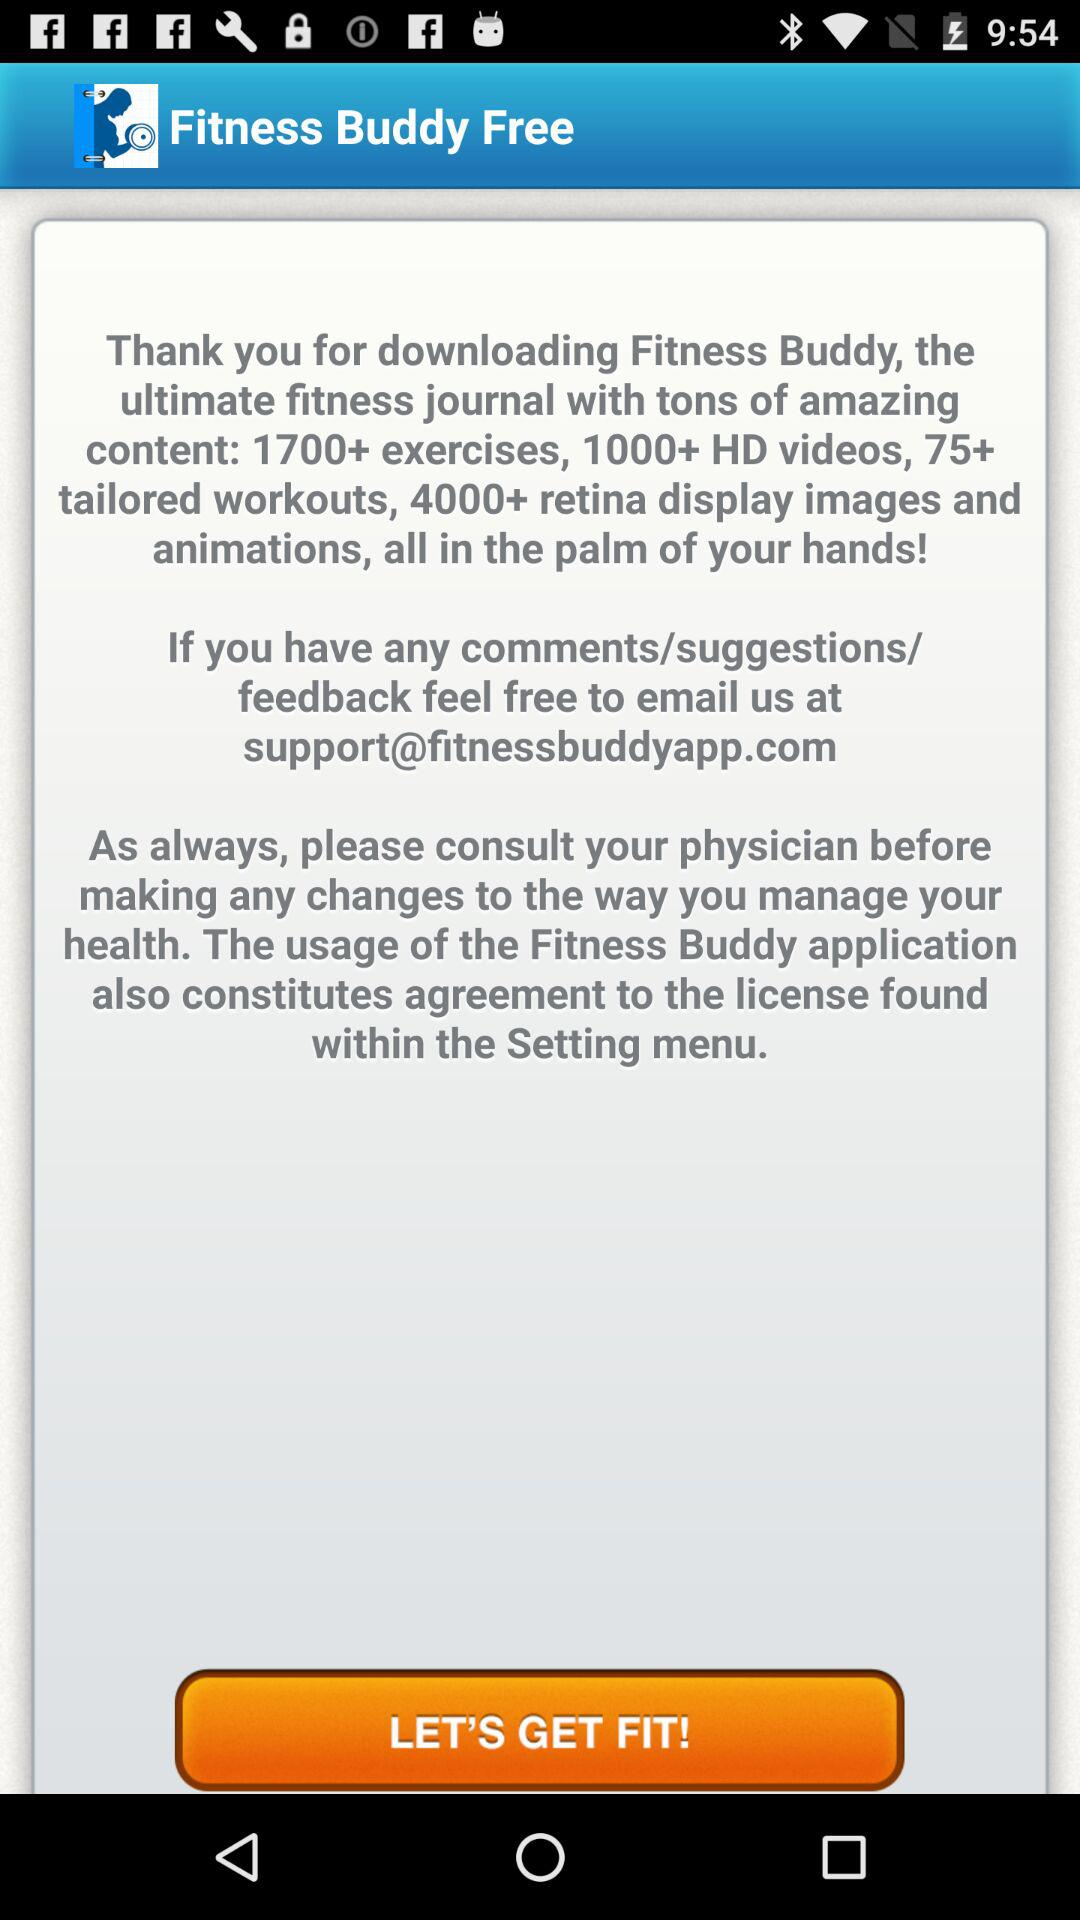What's the email address for comments, suggestions and feedback? The email address is support@fitnessbuddyapp.com. 